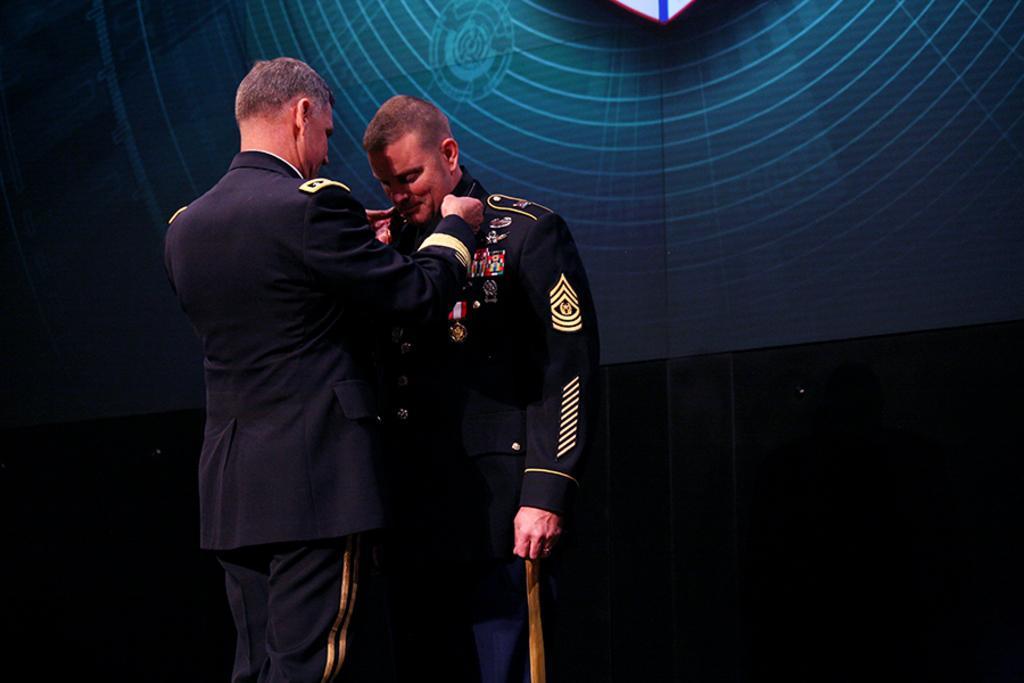In one or two sentences, can you explain what this image depicts? In the center of the image there are two persons standing wearing a blue color uniform. In the background of the image there is a wall. 